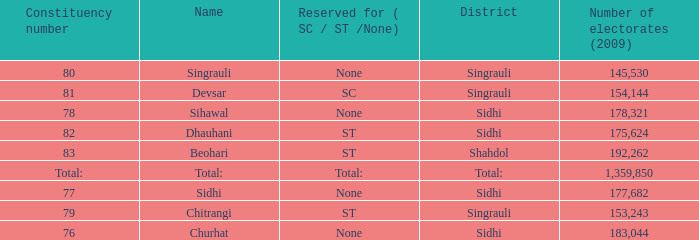What is the district with 79 constituency number? Singrauli. 